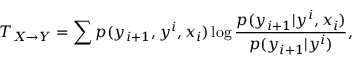<formula> <loc_0><loc_0><loc_500><loc_500>T _ { X \rightarrow Y } = \sum { p ( y _ { i + 1 } , y ^ { i } , x _ { i } ) \log \frac { p ( y _ { i + 1 } | y ^ { i } , x _ { i } ) } { p ( y _ { i + 1 } | y ^ { i } ) } } ,</formula> 